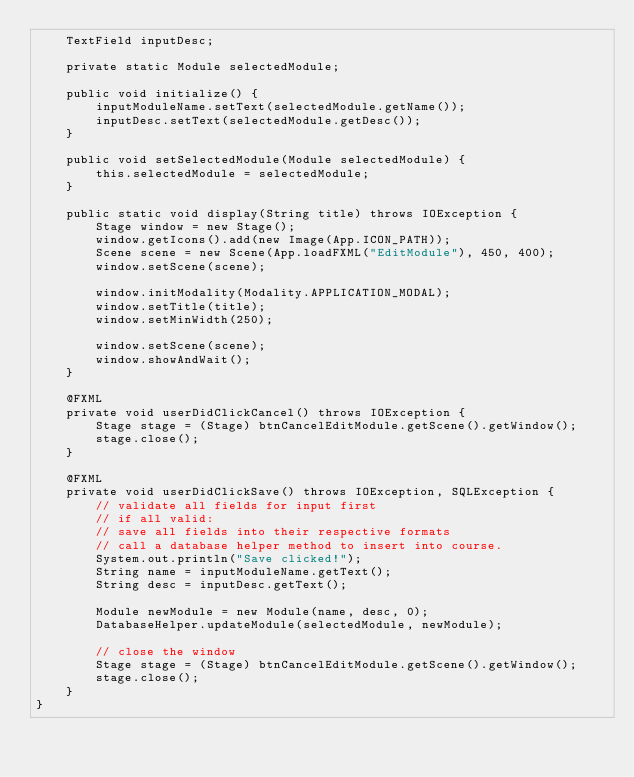Convert code to text. <code><loc_0><loc_0><loc_500><loc_500><_Java_>    TextField inputDesc;
    
    private static Module selectedModule;
    
    public void initialize() {
        inputModuleName.setText(selectedModule.getName());
        inputDesc.setText(selectedModule.getDesc());
    }
    
    public void setSelectedModule(Module selectedModule) {
        this.selectedModule = selectedModule;
    }
    
    public static void display(String title) throws IOException {
        Stage window = new Stage();
        window.getIcons().add(new Image(App.ICON_PATH));
        Scene scene = new Scene(App.loadFXML("EditModule"), 450, 400);
        window.setScene(scene);
        
        window.initModality(Modality.APPLICATION_MODAL);
        window.setTitle(title);
        window.setMinWidth(250);
        
        window.setScene(scene);
        window.showAndWait();
    }
    
    @FXML
    private void userDidClickCancel() throws IOException {
        Stage stage = (Stage) btnCancelEditModule.getScene().getWindow();
        stage.close();
    }
    
    @FXML
    private void userDidClickSave() throws IOException, SQLException {
        // validate all fields for input first
        // if all valid:
        // save all fields into their respective formats
        // call a database helper method to insert into course. 
        System.out.println("Save clicked!");
        String name = inputModuleName.getText();
        String desc = inputDesc.getText();
        
        Module newModule = new Module(name, desc, 0);
        DatabaseHelper.updateModule(selectedModule, newModule);
        
        // close the window
        Stage stage = (Stage) btnCancelEditModule.getScene().getWindow();
        stage.close();
    }
}
</code> 